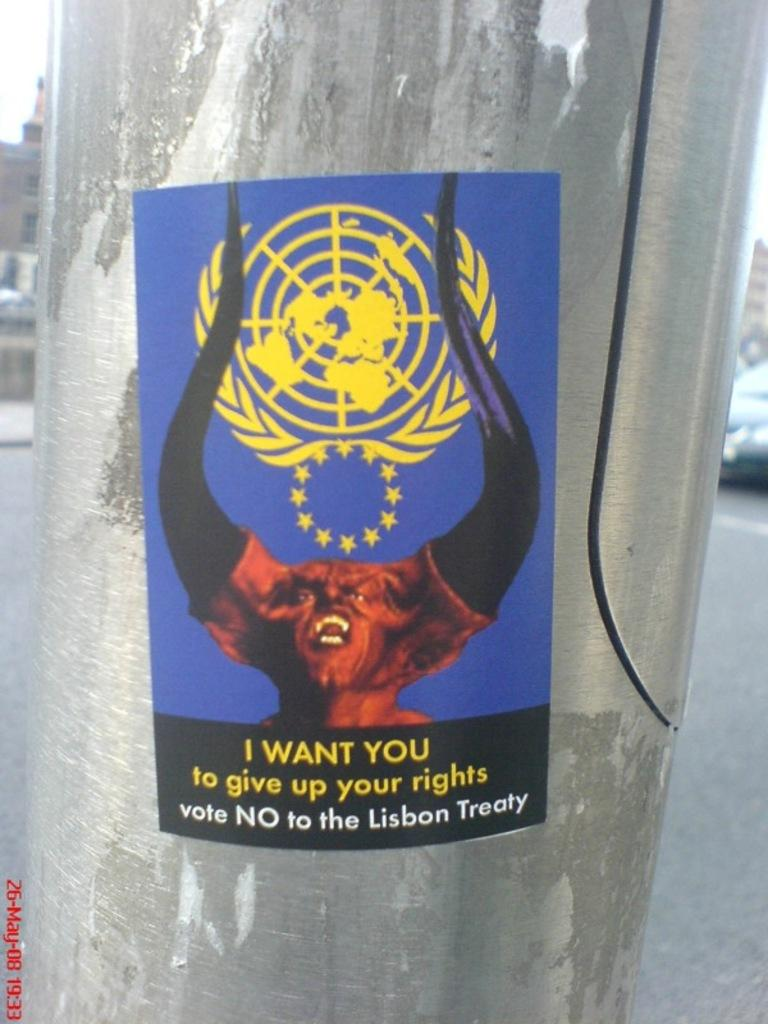What is located in the center of the image? There is a poster on a pole in the center of the image. What can be seen in the background of the image? There are buildings and vehicles on the road in the background of the image. Is there any text visible in the image? Yes, there is some text at the bottom of the image. What type of jeans can be seen hanging on the poster in the image? There are no jeans present in the image; the poster features a different subject. 